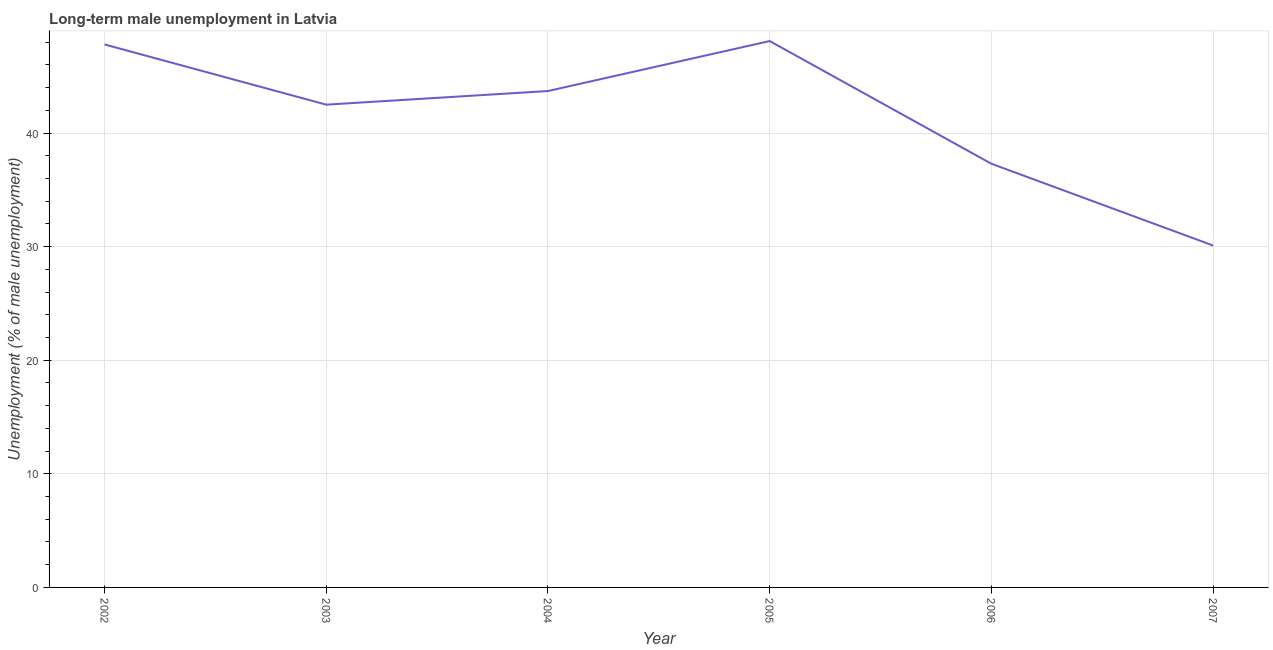What is the long-term male unemployment in 2005?
Provide a succinct answer. 48.1. Across all years, what is the maximum long-term male unemployment?
Offer a terse response. 48.1. Across all years, what is the minimum long-term male unemployment?
Your answer should be very brief. 30.1. What is the sum of the long-term male unemployment?
Offer a terse response. 249.5. What is the average long-term male unemployment per year?
Provide a short and direct response. 41.58. What is the median long-term male unemployment?
Make the answer very short. 43.1. What is the ratio of the long-term male unemployment in 2002 to that in 2004?
Your answer should be compact. 1.09. Is the difference between the long-term male unemployment in 2003 and 2004 greater than the difference between any two years?
Offer a very short reply. No. What is the difference between the highest and the second highest long-term male unemployment?
Ensure brevity in your answer.  0.3. Is the sum of the long-term male unemployment in 2004 and 2006 greater than the maximum long-term male unemployment across all years?
Ensure brevity in your answer.  Yes. What is the difference between the highest and the lowest long-term male unemployment?
Give a very brief answer. 18. How many years are there in the graph?
Your answer should be very brief. 6. What is the difference between two consecutive major ticks on the Y-axis?
Make the answer very short. 10. Are the values on the major ticks of Y-axis written in scientific E-notation?
Your answer should be compact. No. Does the graph contain any zero values?
Give a very brief answer. No. What is the title of the graph?
Your response must be concise. Long-term male unemployment in Latvia. What is the label or title of the Y-axis?
Ensure brevity in your answer.  Unemployment (% of male unemployment). What is the Unemployment (% of male unemployment) of 2002?
Make the answer very short. 47.8. What is the Unemployment (% of male unemployment) in 2003?
Your response must be concise. 42.5. What is the Unemployment (% of male unemployment) of 2004?
Provide a short and direct response. 43.7. What is the Unemployment (% of male unemployment) of 2005?
Make the answer very short. 48.1. What is the Unemployment (% of male unemployment) of 2006?
Keep it short and to the point. 37.3. What is the Unemployment (% of male unemployment) of 2007?
Keep it short and to the point. 30.1. What is the difference between the Unemployment (% of male unemployment) in 2002 and 2007?
Offer a very short reply. 17.7. What is the difference between the Unemployment (% of male unemployment) in 2003 and 2006?
Give a very brief answer. 5.2. What is the difference between the Unemployment (% of male unemployment) in 2004 and 2005?
Offer a terse response. -4.4. What is the difference between the Unemployment (% of male unemployment) in 2004 and 2007?
Your answer should be very brief. 13.6. What is the difference between the Unemployment (% of male unemployment) in 2006 and 2007?
Provide a succinct answer. 7.2. What is the ratio of the Unemployment (% of male unemployment) in 2002 to that in 2003?
Keep it short and to the point. 1.12. What is the ratio of the Unemployment (% of male unemployment) in 2002 to that in 2004?
Your answer should be compact. 1.09. What is the ratio of the Unemployment (% of male unemployment) in 2002 to that in 2006?
Offer a terse response. 1.28. What is the ratio of the Unemployment (% of male unemployment) in 2002 to that in 2007?
Provide a succinct answer. 1.59. What is the ratio of the Unemployment (% of male unemployment) in 2003 to that in 2005?
Keep it short and to the point. 0.88. What is the ratio of the Unemployment (% of male unemployment) in 2003 to that in 2006?
Make the answer very short. 1.14. What is the ratio of the Unemployment (% of male unemployment) in 2003 to that in 2007?
Provide a succinct answer. 1.41. What is the ratio of the Unemployment (% of male unemployment) in 2004 to that in 2005?
Provide a succinct answer. 0.91. What is the ratio of the Unemployment (% of male unemployment) in 2004 to that in 2006?
Make the answer very short. 1.17. What is the ratio of the Unemployment (% of male unemployment) in 2004 to that in 2007?
Offer a very short reply. 1.45. What is the ratio of the Unemployment (% of male unemployment) in 2005 to that in 2006?
Your answer should be compact. 1.29. What is the ratio of the Unemployment (% of male unemployment) in 2005 to that in 2007?
Your answer should be compact. 1.6. What is the ratio of the Unemployment (% of male unemployment) in 2006 to that in 2007?
Your answer should be compact. 1.24. 